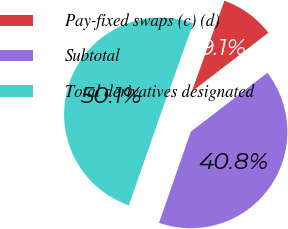Convert chart to OTSL. <chart><loc_0><loc_0><loc_500><loc_500><pie_chart><fcel>Pay-fixed swaps (c) (d)<fcel>Subtotal<fcel>Total derivatives designated<nl><fcel>9.09%<fcel>40.77%<fcel>50.14%<nl></chart> 